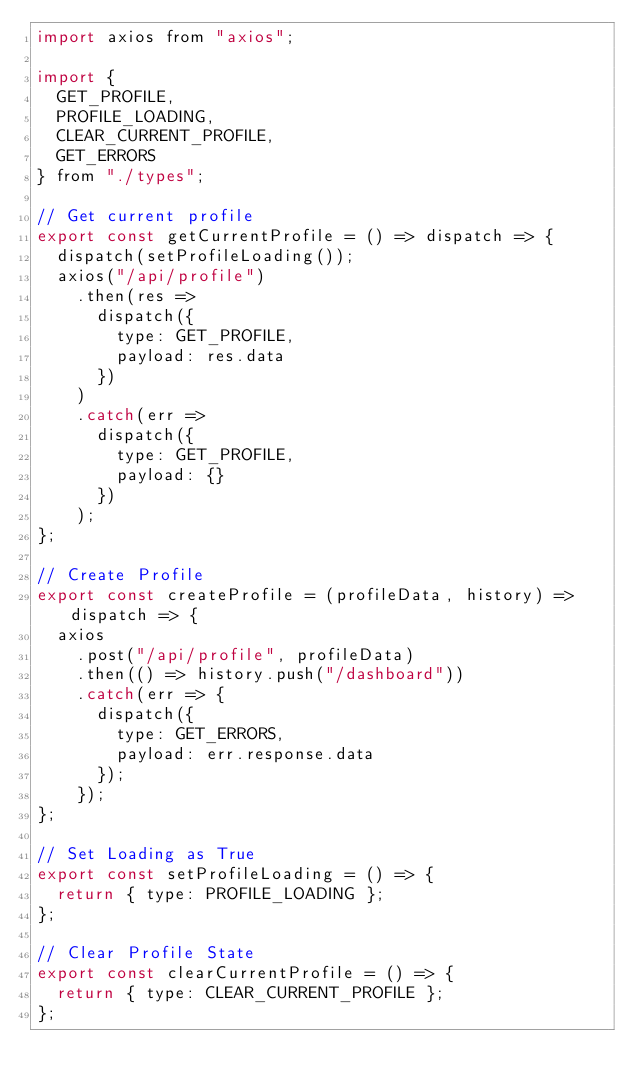Convert code to text. <code><loc_0><loc_0><loc_500><loc_500><_JavaScript_>import axios from "axios";

import {
  GET_PROFILE,
  PROFILE_LOADING,
  CLEAR_CURRENT_PROFILE,
  GET_ERRORS
} from "./types";

// Get current profile
export const getCurrentProfile = () => dispatch => {
  dispatch(setProfileLoading());
  axios("/api/profile")
    .then(res =>
      dispatch({
        type: GET_PROFILE,
        payload: res.data
      })
    )
    .catch(err =>
      dispatch({
        type: GET_PROFILE,
        payload: {}
      })
    );
};

// Create Profile
export const createProfile = (profileData, history) => dispatch => {
  axios
    .post("/api/profile", profileData)
    .then(() => history.push("/dashboard"))
    .catch(err => {
      dispatch({
        type: GET_ERRORS,
        payload: err.response.data
      });
    });
};

// Set Loading as True
export const setProfileLoading = () => {
  return { type: PROFILE_LOADING };
};

// Clear Profile State
export const clearCurrentProfile = () => {
  return { type: CLEAR_CURRENT_PROFILE };
};
</code> 